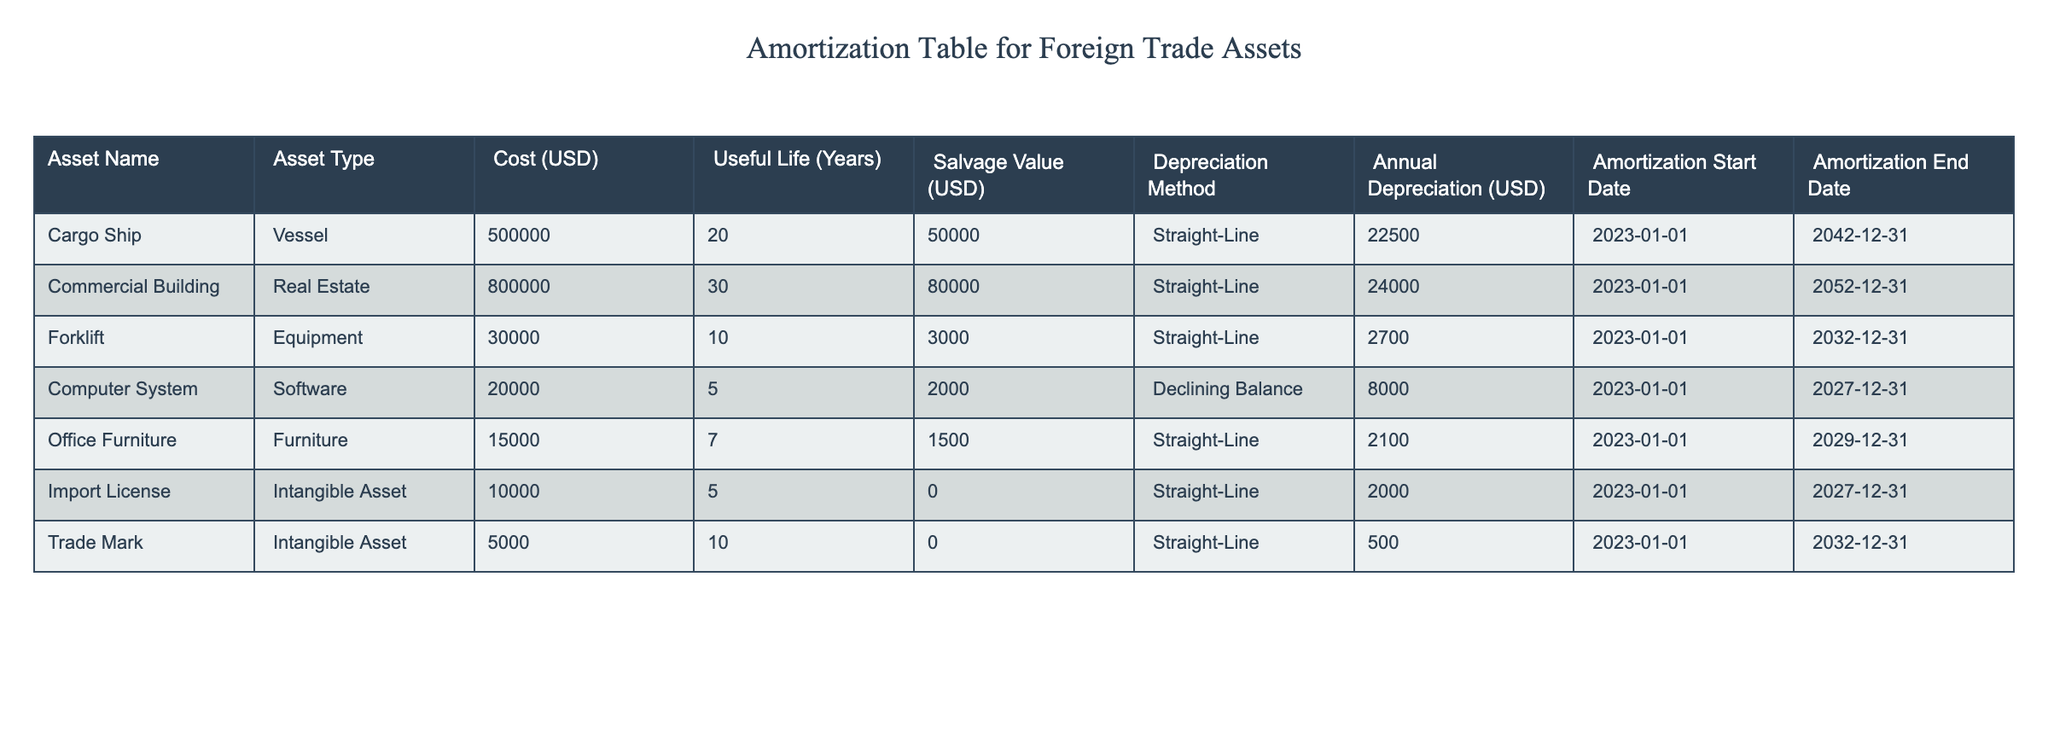What is the annual depreciation of the cargo ship? The annual depreciation value for the cargo ship, as listed in the table, is 22500 USD.
Answer: 22500 USD How many years is the useful life of the commercial building? The useful life of the commercial building is given in the table as 30 years.
Answer: 30 years Which asset has the highest salvage value? To find the asset with the highest salvage value, we compare the salvage values listed: Cargo Ship (50000 USD), Commercial Building (80000 USD), Forklift (3000 USD), Computer System (2000 USD), Office Furniture (1500 USD), Import License (0 USD), and Trade Mark (0 USD). The Commercial Building has the highest salvage value of 80000 USD.
Answer: Commercial Building What is the total annual depreciation for all assets combined? To calculate the total annual depreciation for all assets, we sum the individual annual depreciation values: 22500 + 24000 + 2700 + 8000 + 2100 + 2000 + 500 = 60000 USD.
Answer: 60000 USD Is the annual depreciation of the forklift more than that of the computer system? The annual depreciation for the forklift is 2700 USD, whereas the computer system has an annual depreciation of 8000 USD. Since 2700 is less than 8000, the statement is false.
Answer: No Which asset type has the shortest useful life? The asset type with the shortest useful life can be determined by looking at the useful life values: Cargo Ship (20 years), Commercial Building (30 years), Forklift (10 years), Computer System (5 years), Office Furniture (7 years), Import License (5 years), and Trade Mark (10 years). The Computer System and Import License both have the shortest useful life of 5 years.
Answer: Computer System and Import License What is the average salvage value of all the assets? To find the average salvage value, we first sum the salvage values: 50000 + 80000 + 3000 + 2000 + 1500 + 0 + 0 = 134500 USD. There are 7 assets, so the average salvage value is 134500 / 7 ≈ 19214.29 USD.
Answer: 19214.29 USD Does the Cargo Ship depreciate on a declining balance method? Referring to the table, the Cargo Ship uses the Straight-Line method for depreciation, not the Declining Balance method. Therefore, this statement is false.
Answer: No What will be the date when the forklift amortization ends? The amortization end date for the forklift, as found in the table, is 2032-12-31.
Answer: 2032-12-31 